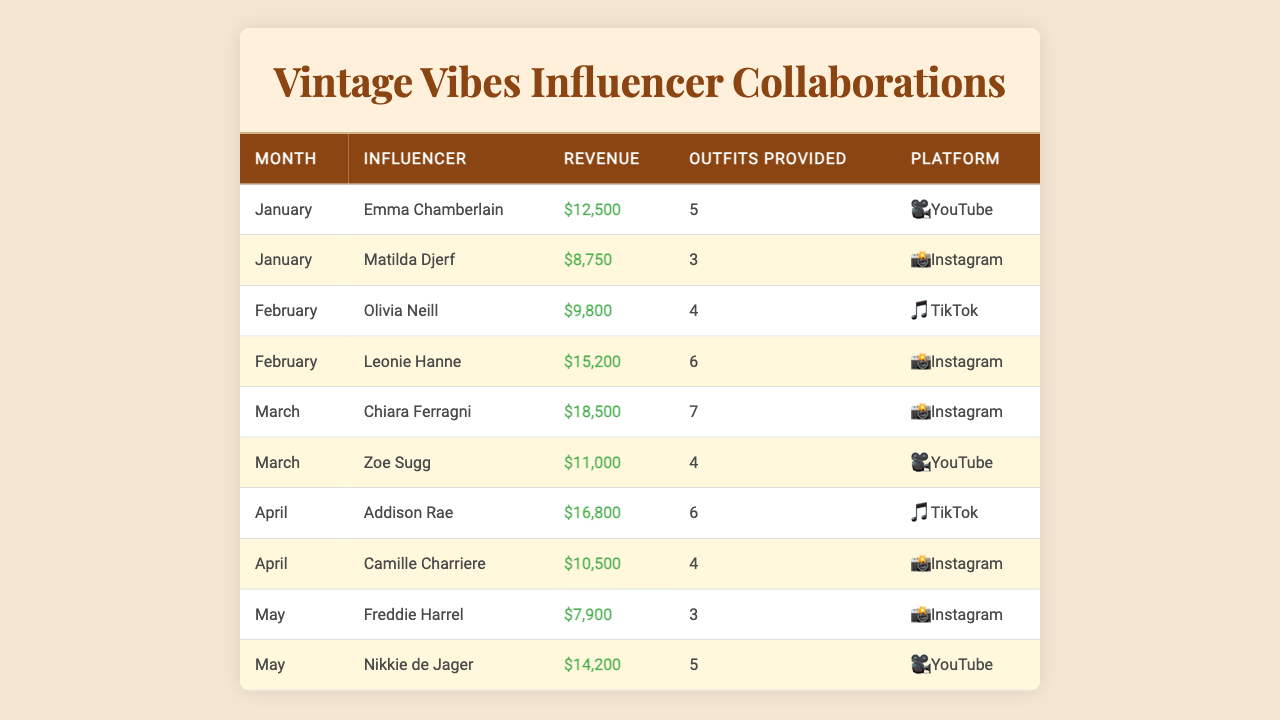What is the total revenue generated by all influencers in January? The revenue for January includes Emma Chamberlain ($12,500) and Matilda Djerf ($8,750). Adding these amounts, $12,500 + $8,750 = $21,250.
Answer: $21,250 Who collaborated with the highest revenue in March? In March, Chiara Ferragni generated the highest revenue of $18,500 compared to Zoe Sugg's $11,000.
Answer: Chiara Ferragni How many outfits were provided by Nikkie de Jager? Nikkie de Jager provided a total of 5 outfits as listed in the table.
Answer: 5 outfits What is the average revenue for influencer collaborations across all months? The total revenue is $12500 + $8750 + $9800 + $15200 + $18500 + $11000 + $16800 + $10500 + $7900 + $14200 = $113,650. There are 10 entries, so the average is $113,650 / 10 = $11,365.
Answer: $11,365 Did any influencer provide more than 6 outfits in a single month? Yes, in March, Chiara Ferragni provided 7 outfits, which is more than 6.
Answer: Yes Which social media platform had the highest total revenue in April? In April, Addison Rae generated $16,800 on TikTok while Camille Charriere earned $10,500 on Instagram. Thus, TikTok had the higher revenue of $16,800.
Answer: TikTok What is the difference in revenue between the highest and lowest earning influencer in February? In February, Olivia Neill earned $9,800 and Leonie Hanne earned $15,200. The difference is $15,200 - $9,800 = $5,400.
Answer: $5,400 Which influencer had the lowest revenue across all months? Freddie Harrel had the lowest revenue of $7,900 in May compared to others.
Answer: Freddie Harrel What is the total revenue from all collaborations on Instagram? The Instagram collaborations are Matilda Djerf ($8,750), Leonie Hanne ($15,200), Chiara Ferragni ($18,500), Camille Charriere ($10,500), and Freddie Harrel ($7,900). Total = $8,750 + $15,200 + $18,500 + $10,500 + $7,900 = $60,850.
Answer: $60,850 Which influencer's revenue was the closest to $14,000? Nikkie de Jager's revenue was $14,200, which is the closest to $14,000, earning only $200 more.
Answer: Nikkie de Jager 